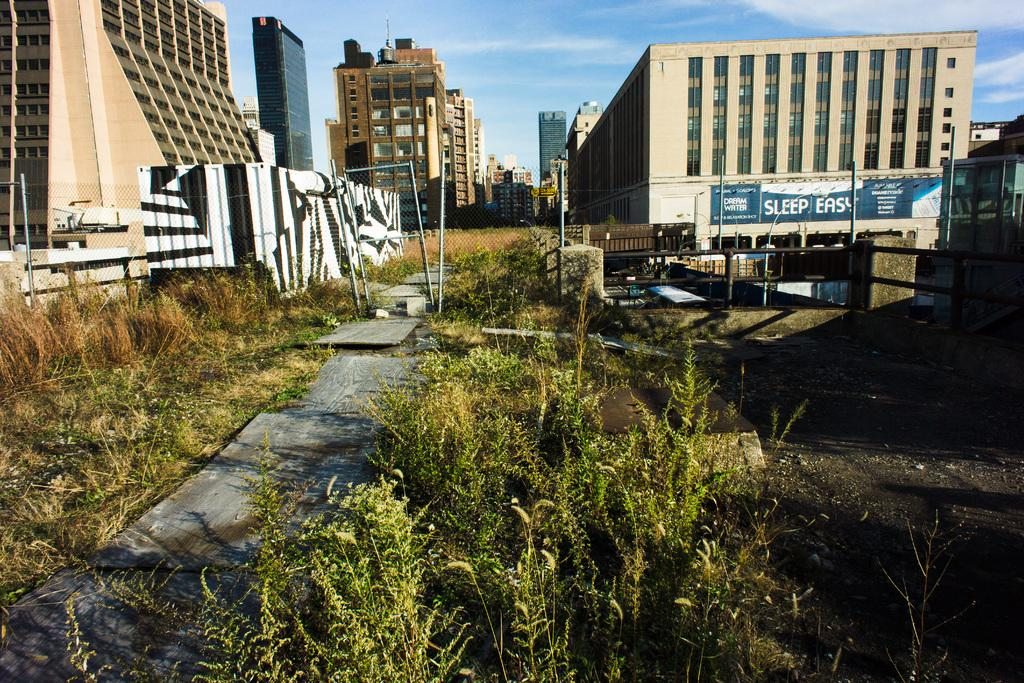What type of structures can be seen in the image? There are many buildings in the image. What type of vegetation is present at the bottom of the image? There are plants at the bottom of the image. What architectural features are visible in the front of the image? Pillars and poles are visible in the front of the image. What is visible at the top of the image? The sky is visible at the top of the image. What is present at the bottom of the image besides the plants? The ground is present at the bottom of the image. What verse is being recited by the plants in the image? There are no plants reciting verses in the image; they are simply plants. How does the image stop the fire from spreading? The image does not depict a fire or any action to stop it; it is a still image of buildings, plants, pillars, and the sky. 